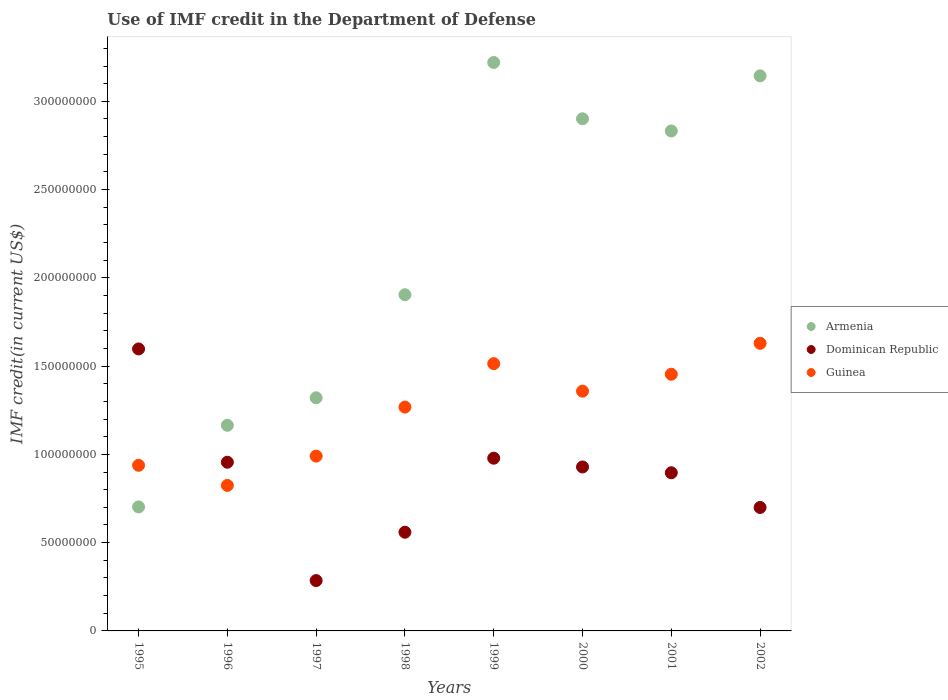How many different coloured dotlines are there?
Offer a very short reply. 3. Is the number of dotlines equal to the number of legend labels?
Ensure brevity in your answer.  Yes. What is the IMF credit in the Department of Defense in Armenia in 1995?
Ensure brevity in your answer.  7.02e+07. Across all years, what is the maximum IMF credit in the Department of Defense in Armenia?
Give a very brief answer. 3.22e+08. Across all years, what is the minimum IMF credit in the Department of Defense in Armenia?
Offer a terse response. 7.02e+07. What is the total IMF credit in the Department of Defense in Guinea in the graph?
Your answer should be very brief. 9.98e+08. What is the difference between the IMF credit in the Department of Defense in Guinea in 1995 and that in 1999?
Make the answer very short. -5.76e+07. What is the difference between the IMF credit in the Department of Defense in Guinea in 1998 and the IMF credit in the Department of Defense in Armenia in 2000?
Ensure brevity in your answer.  -1.63e+08. What is the average IMF credit in the Department of Defense in Armenia per year?
Offer a very short reply. 2.15e+08. In the year 2002, what is the difference between the IMF credit in the Department of Defense in Armenia and IMF credit in the Department of Defense in Dominican Republic?
Keep it short and to the point. 2.44e+08. What is the ratio of the IMF credit in the Department of Defense in Dominican Republic in 1996 to that in 1999?
Provide a short and direct response. 0.98. Is the IMF credit in the Department of Defense in Armenia in 1999 less than that in 2002?
Your response must be concise. No. What is the difference between the highest and the second highest IMF credit in the Department of Defense in Armenia?
Keep it short and to the point. 7.57e+06. What is the difference between the highest and the lowest IMF credit in the Department of Defense in Guinea?
Give a very brief answer. 8.05e+07. In how many years, is the IMF credit in the Department of Defense in Guinea greater than the average IMF credit in the Department of Defense in Guinea taken over all years?
Offer a very short reply. 5. Is the sum of the IMF credit in the Department of Defense in Dominican Republic in 1997 and 2002 greater than the maximum IMF credit in the Department of Defense in Guinea across all years?
Keep it short and to the point. No. Is it the case that in every year, the sum of the IMF credit in the Department of Defense in Dominican Republic and IMF credit in the Department of Defense in Guinea  is greater than the IMF credit in the Department of Defense in Armenia?
Provide a short and direct response. No. Does the IMF credit in the Department of Defense in Dominican Republic monotonically increase over the years?
Offer a terse response. No. Is the IMF credit in the Department of Defense in Armenia strictly greater than the IMF credit in the Department of Defense in Dominican Republic over the years?
Keep it short and to the point. No. How many dotlines are there?
Your answer should be very brief. 3. What is the difference between two consecutive major ticks on the Y-axis?
Your answer should be very brief. 5.00e+07. Are the values on the major ticks of Y-axis written in scientific E-notation?
Offer a terse response. No. Does the graph contain any zero values?
Provide a succinct answer. No. How many legend labels are there?
Ensure brevity in your answer.  3. How are the legend labels stacked?
Offer a very short reply. Vertical. What is the title of the graph?
Make the answer very short. Use of IMF credit in the Department of Defense. Does "Madagascar" appear as one of the legend labels in the graph?
Offer a very short reply. No. What is the label or title of the X-axis?
Offer a very short reply. Years. What is the label or title of the Y-axis?
Provide a short and direct response. IMF credit(in current US$). What is the IMF credit(in current US$) in Armenia in 1995?
Your answer should be compact. 7.02e+07. What is the IMF credit(in current US$) of Dominican Republic in 1995?
Your answer should be compact. 1.60e+08. What is the IMF credit(in current US$) of Guinea in 1995?
Give a very brief answer. 9.38e+07. What is the IMF credit(in current US$) of Armenia in 1996?
Your answer should be very brief. 1.16e+08. What is the IMF credit(in current US$) of Dominican Republic in 1996?
Keep it short and to the point. 9.56e+07. What is the IMF credit(in current US$) of Guinea in 1996?
Keep it short and to the point. 8.24e+07. What is the IMF credit(in current US$) of Armenia in 1997?
Keep it short and to the point. 1.32e+08. What is the IMF credit(in current US$) in Dominican Republic in 1997?
Your response must be concise. 2.85e+07. What is the IMF credit(in current US$) of Guinea in 1997?
Offer a terse response. 9.90e+07. What is the IMF credit(in current US$) of Armenia in 1998?
Make the answer very short. 1.90e+08. What is the IMF credit(in current US$) in Dominican Republic in 1998?
Offer a very short reply. 5.59e+07. What is the IMF credit(in current US$) in Guinea in 1998?
Ensure brevity in your answer.  1.27e+08. What is the IMF credit(in current US$) of Armenia in 1999?
Provide a succinct answer. 3.22e+08. What is the IMF credit(in current US$) of Dominican Republic in 1999?
Provide a short and direct response. 9.78e+07. What is the IMF credit(in current US$) of Guinea in 1999?
Offer a very short reply. 1.51e+08. What is the IMF credit(in current US$) in Armenia in 2000?
Give a very brief answer. 2.90e+08. What is the IMF credit(in current US$) in Dominican Republic in 2000?
Give a very brief answer. 9.29e+07. What is the IMF credit(in current US$) in Guinea in 2000?
Ensure brevity in your answer.  1.36e+08. What is the IMF credit(in current US$) in Armenia in 2001?
Keep it short and to the point. 2.83e+08. What is the IMF credit(in current US$) of Dominican Republic in 2001?
Offer a terse response. 8.96e+07. What is the IMF credit(in current US$) in Guinea in 2001?
Keep it short and to the point. 1.45e+08. What is the IMF credit(in current US$) in Armenia in 2002?
Your answer should be very brief. 3.14e+08. What is the IMF credit(in current US$) in Dominican Republic in 2002?
Offer a very short reply. 6.99e+07. What is the IMF credit(in current US$) of Guinea in 2002?
Provide a succinct answer. 1.63e+08. Across all years, what is the maximum IMF credit(in current US$) in Armenia?
Your answer should be very brief. 3.22e+08. Across all years, what is the maximum IMF credit(in current US$) of Dominican Republic?
Provide a succinct answer. 1.60e+08. Across all years, what is the maximum IMF credit(in current US$) of Guinea?
Your answer should be very brief. 1.63e+08. Across all years, what is the minimum IMF credit(in current US$) in Armenia?
Keep it short and to the point. 7.02e+07. Across all years, what is the minimum IMF credit(in current US$) in Dominican Republic?
Provide a succinct answer. 2.85e+07. Across all years, what is the minimum IMF credit(in current US$) in Guinea?
Offer a very short reply. 8.24e+07. What is the total IMF credit(in current US$) in Armenia in the graph?
Ensure brevity in your answer.  1.72e+09. What is the total IMF credit(in current US$) in Dominican Republic in the graph?
Make the answer very short. 6.90e+08. What is the total IMF credit(in current US$) in Guinea in the graph?
Make the answer very short. 9.98e+08. What is the difference between the IMF credit(in current US$) of Armenia in 1995 and that in 1996?
Ensure brevity in your answer.  -4.62e+07. What is the difference between the IMF credit(in current US$) of Dominican Republic in 1995 and that in 1996?
Make the answer very short. 6.42e+07. What is the difference between the IMF credit(in current US$) in Guinea in 1995 and that in 1996?
Your response must be concise. 1.14e+07. What is the difference between the IMF credit(in current US$) in Armenia in 1995 and that in 1997?
Offer a terse response. -6.18e+07. What is the difference between the IMF credit(in current US$) in Dominican Republic in 1995 and that in 1997?
Keep it short and to the point. 1.31e+08. What is the difference between the IMF credit(in current US$) in Guinea in 1995 and that in 1997?
Your answer should be compact. -5.21e+06. What is the difference between the IMF credit(in current US$) of Armenia in 1995 and that in 1998?
Your answer should be very brief. -1.20e+08. What is the difference between the IMF credit(in current US$) in Dominican Republic in 1995 and that in 1998?
Your response must be concise. 1.04e+08. What is the difference between the IMF credit(in current US$) in Guinea in 1995 and that in 1998?
Your answer should be compact. -3.30e+07. What is the difference between the IMF credit(in current US$) in Armenia in 1995 and that in 1999?
Provide a succinct answer. -2.52e+08. What is the difference between the IMF credit(in current US$) of Dominican Republic in 1995 and that in 1999?
Your response must be concise. 6.19e+07. What is the difference between the IMF credit(in current US$) of Guinea in 1995 and that in 1999?
Your answer should be very brief. -5.76e+07. What is the difference between the IMF credit(in current US$) of Armenia in 1995 and that in 2000?
Give a very brief answer. -2.20e+08. What is the difference between the IMF credit(in current US$) of Dominican Republic in 1995 and that in 2000?
Make the answer very short. 6.69e+07. What is the difference between the IMF credit(in current US$) in Guinea in 1995 and that in 2000?
Your answer should be very brief. -4.20e+07. What is the difference between the IMF credit(in current US$) of Armenia in 1995 and that in 2001?
Offer a very short reply. -2.13e+08. What is the difference between the IMF credit(in current US$) of Dominican Republic in 1995 and that in 2001?
Provide a succinct answer. 7.01e+07. What is the difference between the IMF credit(in current US$) of Guinea in 1995 and that in 2001?
Make the answer very short. -5.16e+07. What is the difference between the IMF credit(in current US$) in Armenia in 1995 and that in 2002?
Provide a succinct answer. -2.44e+08. What is the difference between the IMF credit(in current US$) of Dominican Republic in 1995 and that in 2002?
Your answer should be very brief. 8.98e+07. What is the difference between the IMF credit(in current US$) in Guinea in 1995 and that in 2002?
Keep it short and to the point. -6.91e+07. What is the difference between the IMF credit(in current US$) of Armenia in 1996 and that in 1997?
Offer a very short reply. -1.56e+07. What is the difference between the IMF credit(in current US$) in Dominican Republic in 1996 and that in 1997?
Make the answer very short. 6.70e+07. What is the difference between the IMF credit(in current US$) of Guinea in 1996 and that in 1997?
Your answer should be very brief. -1.66e+07. What is the difference between the IMF credit(in current US$) in Armenia in 1996 and that in 1998?
Give a very brief answer. -7.40e+07. What is the difference between the IMF credit(in current US$) in Dominican Republic in 1996 and that in 1998?
Provide a succinct answer. 3.97e+07. What is the difference between the IMF credit(in current US$) of Guinea in 1996 and that in 1998?
Your answer should be very brief. -4.44e+07. What is the difference between the IMF credit(in current US$) in Armenia in 1996 and that in 1999?
Ensure brevity in your answer.  -2.06e+08. What is the difference between the IMF credit(in current US$) in Dominican Republic in 1996 and that in 1999?
Your answer should be very brief. -2.28e+06. What is the difference between the IMF credit(in current US$) in Guinea in 1996 and that in 1999?
Keep it short and to the point. -6.90e+07. What is the difference between the IMF credit(in current US$) of Armenia in 1996 and that in 2000?
Ensure brevity in your answer.  -1.74e+08. What is the difference between the IMF credit(in current US$) of Dominican Republic in 1996 and that in 2000?
Provide a succinct answer. 2.68e+06. What is the difference between the IMF credit(in current US$) in Guinea in 1996 and that in 2000?
Your response must be concise. -5.34e+07. What is the difference between the IMF credit(in current US$) of Armenia in 1996 and that in 2001?
Keep it short and to the point. -1.67e+08. What is the difference between the IMF credit(in current US$) in Dominican Republic in 1996 and that in 2001?
Your answer should be compact. 5.97e+06. What is the difference between the IMF credit(in current US$) of Guinea in 1996 and that in 2001?
Give a very brief answer. -6.30e+07. What is the difference between the IMF credit(in current US$) of Armenia in 1996 and that in 2002?
Your answer should be very brief. -1.98e+08. What is the difference between the IMF credit(in current US$) in Dominican Republic in 1996 and that in 2002?
Your answer should be very brief. 2.56e+07. What is the difference between the IMF credit(in current US$) in Guinea in 1996 and that in 2002?
Make the answer very short. -8.05e+07. What is the difference between the IMF credit(in current US$) in Armenia in 1997 and that in 1998?
Provide a short and direct response. -5.84e+07. What is the difference between the IMF credit(in current US$) of Dominican Republic in 1997 and that in 1998?
Keep it short and to the point. -2.74e+07. What is the difference between the IMF credit(in current US$) in Guinea in 1997 and that in 1998?
Your response must be concise. -2.78e+07. What is the difference between the IMF credit(in current US$) of Armenia in 1997 and that in 1999?
Provide a succinct answer. -1.90e+08. What is the difference between the IMF credit(in current US$) of Dominican Republic in 1997 and that in 1999?
Your answer should be compact. -6.93e+07. What is the difference between the IMF credit(in current US$) of Guinea in 1997 and that in 1999?
Offer a terse response. -5.24e+07. What is the difference between the IMF credit(in current US$) of Armenia in 1997 and that in 2000?
Your response must be concise. -1.58e+08. What is the difference between the IMF credit(in current US$) in Dominican Republic in 1997 and that in 2000?
Offer a terse response. -6.44e+07. What is the difference between the IMF credit(in current US$) in Guinea in 1997 and that in 2000?
Provide a short and direct response. -3.68e+07. What is the difference between the IMF credit(in current US$) of Armenia in 1997 and that in 2001?
Your answer should be very brief. -1.51e+08. What is the difference between the IMF credit(in current US$) of Dominican Republic in 1997 and that in 2001?
Offer a terse response. -6.11e+07. What is the difference between the IMF credit(in current US$) of Guinea in 1997 and that in 2001?
Give a very brief answer. -4.64e+07. What is the difference between the IMF credit(in current US$) in Armenia in 1997 and that in 2002?
Provide a succinct answer. -1.82e+08. What is the difference between the IMF credit(in current US$) of Dominican Republic in 1997 and that in 2002?
Provide a succinct answer. -4.14e+07. What is the difference between the IMF credit(in current US$) of Guinea in 1997 and that in 2002?
Provide a succinct answer. -6.39e+07. What is the difference between the IMF credit(in current US$) in Armenia in 1998 and that in 1999?
Your answer should be very brief. -1.32e+08. What is the difference between the IMF credit(in current US$) of Dominican Republic in 1998 and that in 1999?
Keep it short and to the point. -4.19e+07. What is the difference between the IMF credit(in current US$) of Guinea in 1998 and that in 1999?
Give a very brief answer. -2.46e+07. What is the difference between the IMF credit(in current US$) of Armenia in 1998 and that in 2000?
Ensure brevity in your answer.  -9.97e+07. What is the difference between the IMF credit(in current US$) of Dominican Republic in 1998 and that in 2000?
Make the answer very short. -3.70e+07. What is the difference between the IMF credit(in current US$) in Guinea in 1998 and that in 2000?
Provide a succinct answer. -9.02e+06. What is the difference between the IMF credit(in current US$) of Armenia in 1998 and that in 2001?
Offer a terse response. -9.28e+07. What is the difference between the IMF credit(in current US$) of Dominican Republic in 1998 and that in 2001?
Provide a succinct answer. -3.37e+07. What is the difference between the IMF credit(in current US$) of Guinea in 1998 and that in 2001?
Offer a terse response. -1.86e+07. What is the difference between the IMF credit(in current US$) of Armenia in 1998 and that in 2002?
Keep it short and to the point. -1.24e+08. What is the difference between the IMF credit(in current US$) of Dominican Republic in 1998 and that in 2002?
Make the answer very short. -1.40e+07. What is the difference between the IMF credit(in current US$) in Guinea in 1998 and that in 2002?
Offer a terse response. -3.61e+07. What is the difference between the IMF credit(in current US$) in Armenia in 1999 and that in 2000?
Ensure brevity in your answer.  3.19e+07. What is the difference between the IMF credit(in current US$) in Dominican Republic in 1999 and that in 2000?
Make the answer very short. 4.96e+06. What is the difference between the IMF credit(in current US$) in Guinea in 1999 and that in 2000?
Provide a short and direct response. 1.56e+07. What is the difference between the IMF credit(in current US$) in Armenia in 1999 and that in 2001?
Make the answer very short. 3.88e+07. What is the difference between the IMF credit(in current US$) of Dominican Republic in 1999 and that in 2001?
Provide a short and direct response. 8.25e+06. What is the difference between the IMF credit(in current US$) in Guinea in 1999 and that in 2001?
Your answer should be compact. 6.01e+06. What is the difference between the IMF credit(in current US$) in Armenia in 1999 and that in 2002?
Make the answer very short. 7.57e+06. What is the difference between the IMF credit(in current US$) of Dominican Republic in 1999 and that in 2002?
Offer a very short reply. 2.79e+07. What is the difference between the IMF credit(in current US$) in Guinea in 1999 and that in 2002?
Offer a terse response. -1.15e+07. What is the difference between the IMF credit(in current US$) of Armenia in 2000 and that in 2001?
Your response must be concise. 6.90e+06. What is the difference between the IMF credit(in current US$) of Dominican Republic in 2000 and that in 2001?
Provide a succinct answer. 3.29e+06. What is the difference between the IMF credit(in current US$) in Guinea in 2000 and that in 2001?
Keep it short and to the point. -9.59e+06. What is the difference between the IMF credit(in current US$) of Armenia in 2000 and that in 2002?
Offer a terse response. -2.43e+07. What is the difference between the IMF credit(in current US$) of Dominican Republic in 2000 and that in 2002?
Offer a very short reply. 2.30e+07. What is the difference between the IMF credit(in current US$) of Guinea in 2000 and that in 2002?
Provide a succinct answer. -2.71e+07. What is the difference between the IMF credit(in current US$) of Armenia in 2001 and that in 2002?
Keep it short and to the point. -3.12e+07. What is the difference between the IMF credit(in current US$) of Dominican Republic in 2001 and that in 2002?
Offer a terse response. 1.97e+07. What is the difference between the IMF credit(in current US$) in Guinea in 2001 and that in 2002?
Keep it short and to the point. -1.75e+07. What is the difference between the IMF credit(in current US$) of Armenia in 1995 and the IMF credit(in current US$) of Dominican Republic in 1996?
Ensure brevity in your answer.  -2.53e+07. What is the difference between the IMF credit(in current US$) in Armenia in 1995 and the IMF credit(in current US$) in Guinea in 1996?
Offer a very short reply. -1.22e+07. What is the difference between the IMF credit(in current US$) of Dominican Republic in 1995 and the IMF credit(in current US$) of Guinea in 1996?
Provide a succinct answer. 7.73e+07. What is the difference between the IMF credit(in current US$) in Armenia in 1995 and the IMF credit(in current US$) in Dominican Republic in 1997?
Provide a short and direct response. 4.17e+07. What is the difference between the IMF credit(in current US$) of Armenia in 1995 and the IMF credit(in current US$) of Guinea in 1997?
Offer a terse response. -2.88e+07. What is the difference between the IMF credit(in current US$) of Dominican Republic in 1995 and the IMF credit(in current US$) of Guinea in 1997?
Ensure brevity in your answer.  6.07e+07. What is the difference between the IMF credit(in current US$) in Armenia in 1995 and the IMF credit(in current US$) in Dominican Republic in 1998?
Keep it short and to the point. 1.43e+07. What is the difference between the IMF credit(in current US$) in Armenia in 1995 and the IMF credit(in current US$) in Guinea in 1998?
Provide a short and direct response. -5.66e+07. What is the difference between the IMF credit(in current US$) in Dominican Republic in 1995 and the IMF credit(in current US$) in Guinea in 1998?
Ensure brevity in your answer.  3.29e+07. What is the difference between the IMF credit(in current US$) of Armenia in 1995 and the IMF credit(in current US$) of Dominican Republic in 1999?
Offer a terse response. -2.76e+07. What is the difference between the IMF credit(in current US$) in Armenia in 1995 and the IMF credit(in current US$) in Guinea in 1999?
Your response must be concise. -8.12e+07. What is the difference between the IMF credit(in current US$) in Dominican Republic in 1995 and the IMF credit(in current US$) in Guinea in 1999?
Keep it short and to the point. 8.33e+06. What is the difference between the IMF credit(in current US$) of Armenia in 1995 and the IMF credit(in current US$) of Dominican Republic in 2000?
Give a very brief answer. -2.26e+07. What is the difference between the IMF credit(in current US$) in Armenia in 1995 and the IMF credit(in current US$) in Guinea in 2000?
Provide a succinct answer. -6.56e+07. What is the difference between the IMF credit(in current US$) of Dominican Republic in 1995 and the IMF credit(in current US$) of Guinea in 2000?
Offer a terse response. 2.39e+07. What is the difference between the IMF credit(in current US$) in Armenia in 1995 and the IMF credit(in current US$) in Dominican Republic in 2001?
Provide a short and direct response. -1.93e+07. What is the difference between the IMF credit(in current US$) of Armenia in 1995 and the IMF credit(in current US$) of Guinea in 2001?
Your answer should be compact. -7.52e+07. What is the difference between the IMF credit(in current US$) of Dominican Republic in 1995 and the IMF credit(in current US$) of Guinea in 2001?
Your answer should be very brief. 1.43e+07. What is the difference between the IMF credit(in current US$) of Armenia in 1995 and the IMF credit(in current US$) of Dominican Republic in 2002?
Keep it short and to the point. 3.11e+05. What is the difference between the IMF credit(in current US$) in Armenia in 1995 and the IMF credit(in current US$) in Guinea in 2002?
Your response must be concise. -9.27e+07. What is the difference between the IMF credit(in current US$) in Dominican Republic in 1995 and the IMF credit(in current US$) in Guinea in 2002?
Make the answer very short. -3.18e+06. What is the difference between the IMF credit(in current US$) in Armenia in 1996 and the IMF credit(in current US$) in Dominican Republic in 1997?
Make the answer very short. 8.80e+07. What is the difference between the IMF credit(in current US$) in Armenia in 1996 and the IMF credit(in current US$) in Guinea in 1997?
Provide a short and direct response. 1.74e+07. What is the difference between the IMF credit(in current US$) of Dominican Republic in 1996 and the IMF credit(in current US$) of Guinea in 1997?
Offer a terse response. -3.47e+06. What is the difference between the IMF credit(in current US$) in Armenia in 1996 and the IMF credit(in current US$) in Dominican Republic in 1998?
Offer a terse response. 6.06e+07. What is the difference between the IMF credit(in current US$) in Armenia in 1996 and the IMF credit(in current US$) in Guinea in 1998?
Provide a short and direct response. -1.03e+07. What is the difference between the IMF credit(in current US$) of Dominican Republic in 1996 and the IMF credit(in current US$) of Guinea in 1998?
Your answer should be very brief. -3.12e+07. What is the difference between the IMF credit(in current US$) of Armenia in 1996 and the IMF credit(in current US$) of Dominican Republic in 1999?
Provide a succinct answer. 1.86e+07. What is the difference between the IMF credit(in current US$) of Armenia in 1996 and the IMF credit(in current US$) of Guinea in 1999?
Keep it short and to the point. -3.49e+07. What is the difference between the IMF credit(in current US$) in Dominican Republic in 1996 and the IMF credit(in current US$) in Guinea in 1999?
Keep it short and to the point. -5.58e+07. What is the difference between the IMF credit(in current US$) in Armenia in 1996 and the IMF credit(in current US$) in Dominican Republic in 2000?
Provide a short and direct response. 2.36e+07. What is the difference between the IMF credit(in current US$) of Armenia in 1996 and the IMF credit(in current US$) of Guinea in 2000?
Your answer should be compact. -1.93e+07. What is the difference between the IMF credit(in current US$) in Dominican Republic in 1996 and the IMF credit(in current US$) in Guinea in 2000?
Your response must be concise. -4.02e+07. What is the difference between the IMF credit(in current US$) of Armenia in 1996 and the IMF credit(in current US$) of Dominican Republic in 2001?
Provide a short and direct response. 2.69e+07. What is the difference between the IMF credit(in current US$) of Armenia in 1996 and the IMF credit(in current US$) of Guinea in 2001?
Give a very brief answer. -2.89e+07. What is the difference between the IMF credit(in current US$) in Dominican Republic in 1996 and the IMF credit(in current US$) in Guinea in 2001?
Offer a very short reply. -4.98e+07. What is the difference between the IMF credit(in current US$) in Armenia in 1996 and the IMF credit(in current US$) in Dominican Republic in 2002?
Give a very brief answer. 4.65e+07. What is the difference between the IMF credit(in current US$) of Armenia in 1996 and the IMF credit(in current US$) of Guinea in 2002?
Your response must be concise. -4.64e+07. What is the difference between the IMF credit(in current US$) of Dominican Republic in 1996 and the IMF credit(in current US$) of Guinea in 2002?
Offer a very short reply. -6.74e+07. What is the difference between the IMF credit(in current US$) of Armenia in 1997 and the IMF credit(in current US$) of Dominican Republic in 1998?
Offer a terse response. 7.62e+07. What is the difference between the IMF credit(in current US$) in Armenia in 1997 and the IMF credit(in current US$) in Guinea in 1998?
Your response must be concise. 5.27e+06. What is the difference between the IMF credit(in current US$) of Dominican Republic in 1997 and the IMF credit(in current US$) of Guinea in 1998?
Offer a very short reply. -9.83e+07. What is the difference between the IMF credit(in current US$) of Armenia in 1997 and the IMF credit(in current US$) of Dominican Republic in 1999?
Offer a terse response. 3.42e+07. What is the difference between the IMF credit(in current US$) of Armenia in 1997 and the IMF credit(in current US$) of Guinea in 1999?
Give a very brief answer. -1.93e+07. What is the difference between the IMF credit(in current US$) of Dominican Republic in 1997 and the IMF credit(in current US$) of Guinea in 1999?
Your answer should be very brief. -1.23e+08. What is the difference between the IMF credit(in current US$) of Armenia in 1997 and the IMF credit(in current US$) of Dominican Republic in 2000?
Your response must be concise. 3.92e+07. What is the difference between the IMF credit(in current US$) in Armenia in 1997 and the IMF credit(in current US$) in Guinea in 2000?
Ensure brevity in your answer.  -3.74e+06. What is the difference between the IMF credit(in current US$) of Dominican Republic in 1997 and the IMF credit(in current US$) of Guinea in 2000?
Your answer should be compact. -1.07e+08. What is the difference between the IMF credit(in current US$) in Armenia in 1997 and the IMF credit(in current US$) in Dominican Republic in 2001?
Make the answer very short. 4.25e+07. What is the difference between the IMF credit(in current US$) in Armenia in 1997 and the IMF credit(in current US$) in Guinea in 2001?
Your answer should be very brief. -1.33e+07. What is the difference between the IMF credit(in current US$) of Dominican Republic in 1997 and the IMF credit(in current US$) of Guinea in 2001?
Your answer should be very brief. -1.17e+08. What is the difference between the IMF credit(in current US$) of Armenia in 1997 and the IMF credit(in current US$) of Dominican Republic in 2002?
Keep it short and to the point. 6.21e+07. What is the difference between the IMF credit(in current US$) of Armenia in 1997 and the IMF credit(in current US$) of Guinea in 2002?
Provide a short and direct response. -3.09e+07. What is the difference between the IMF credit(in current US$) of Dominican Republic in 1997 and the IMF credit(in current US$) of Guinea in 2002?
Your answer should be very brief. -1.34e+08. What is the difference between the IMF credit(in current US$) of Armenia in 1998 and the IMF credit(in current US$) of Dominican Republic in 1999?
Your answer should be very brief. 9.26e+07. What is the difference between the IMF credit(in current US$) in Armenia in 1998 and the IMF credit(in current US$) in Guinea in 1999?
Your answer should be very brief. 3.90e+07. What is the difference between the IMF credit(in current US$) in Dominican Republic in 1998 and the IMF credit(in current US$) in Guinea in 1999?
Ensure brevity in your answer.  -9.55e+07. What is the difference between the IMF credit(in current US$) in Armenia in 1998 and the IMF credit(in current US$) in Dominican Republic in 2000?
Offer a very short reply. 9.76e+07. What is the difference between the IMF credit(in current US$) of Armenia in 1998 and the IMF credit(in current US$) of Guinea in 2000?
Give a very brief answer. 5.46e+07. What is the difference between the IMF credit(in current US$) in Dominican Republic in 1998 and the IMF credit(in current US$) in Guinea in 2000?
Your answer should be very brief. -7.99e+07. What is the difference between the IMF credit(in current US$) of Armenia in 1998 and the IMF credit(in current US$) of Dominican Republic in 2001?
Provide a short and direct response. 1.01e+08. What is the difference between the IMF credit(in current US$) of Armenia in 1998 and the IMF credit(in current US$) of Guinea in 2001?
Give a very brief answer. 4.51e+07. What is the difference between the IMF credit(in current US$) in Dominican Republic in 1998 and the IMF credit(in current US$) in Guinea in 2001?
Offer a very short reply. -8.95e+07. What is the difference between the IMF credit(in current US$) in Armenia in 1998 and the IMF credit(in current US$) in Dominican Republic in 2002?
Make the answer very short. 1.21e+08. What is the difference between the IMF credit(in current US$) in Armenia in 1998 and the IMF credit(in current US$) in Guinea in 2002?
Provide a short and direct response. 2.75e+07. What is the difference between the IMF credit(in current US$) of Dominican Republic in 1998 and the IMF credit(in current US$) of Guinea in 2002?
Give a very brief answer. -1.07e+08. What is the difference between the IMF credit(in current US$) in Armenia in 1999 and the IMF credit(in current US$) in Dominican Republic in 2000?
Keep it short and to the point. 2.29e+08. What is the difference between the IMF credit(in current US$) in Armenia in 1999 and the IMF credit(in current US$) in Guinea in 2000?
Your response must be concise. 1.86e+08. What is the difference between the IMF credit(in current US$) of Dominican Republic in 1999 and the IMF credit(in current US$) of Guinea in 2000?
Provide a short and direct response. -3.80e+07. What is the difference between the IMF credit(in current US$) of Armenia in 1999 and the IMF credit(in current US$) of Dominican Republic in 2001?
Your answer should be very brief. 2.32e+08. What is the difference between the IMF credit(in current US$) of Armenia in 1999 and the IMF credit(in current US$) of Guinea in 2001?
Provide a short and direct response. 1.77e+08. What is the difference between the IMF credit(in current US$) of Dominican Republic in 1999 and the IMF credit(in current US$) of Guinea in 2001?
Offer a very short reply. -4.75e+07. What is the difference between the IMF credit(in current US$) of Armenia in 1999 and the IMF credit(in current US$) of Dominican Republic in 2002?
Make the answer very short. 2.52e+08. What is the difference between the IMF credit(in current US$) in Armenia in 1999 and the IMF credit(in current US$) in Guinea in 2002?
Give a very brief answer. 1.59e+08. What is the difference between the IMF credit(in current US$) of Dominican Republic in 1999 and the IMF credit(in current US$) of Guinea in 2002?
Provide a succinct answer. -6.51e+07. What is the difference between the IMF credit(in current US$) of Armenia in 2000 and the IMF credit(in current US$) of Dominican Republic in 2001?
Ensure brevity in your answer.  2.01e+08. What is the difference between the IMF credit(in current US$) in Armenia in 2000 and the IMF credit(in current US$) in Guinea in 2001?
Your answer should be very brief. 1.45e+08. What is the difference between the IMF credit(in current US$) of Dominican Republic in 2000 and the IMF credit(in current US$) of Guinea in 2001?
Your answer should be very brief. -5.25e+07. What is the difference between the IMF credit(in current US$) in Armenia in 2000 and the IMF credit(in current US$) in Dominican Republic in 2002?
Offer a very short reply. 2.20e+08. What is the difference between the IMF credit(in current US$) in Armenia in 2000 and the IMF credit(in current US$) in Guinea in 2002?
Your answer should be very brief. 1.27e+08. What is the difference between the IMF credit(in current US$) of Dominican Republic in 2000 and the IMF credit(in current US$) of Guinea in 2002?
Offer a terse response. -7.00e+07. What is the difference between the IMF credit(in current US$) of Armenia in 2001 and the IMF credit(in current US$) of Dominican Republic in 2002?
Your answer should be compact. 2.13e+08. What is the difference between the IMF credit(in current US$) of Armenia in 2001 and the IMF credit(in current US$) of Guinea in 2002?
Provide a short and direct response. 1.20e+08. What is the difference between the IMF credit(in current US$) in Dominican Republic in 2001 and the IMF credit(in current US$) in Guinea in 2002?
Provide a succinct answer. -7.33e+07. What is the average IMF credit(in current US$) in Armenia per year?
Your answer should be very brief. 2.15e+08. What is the average IMF credit(in current US$) in Dominican Republic per year?
Your answer should be very brief. 8.62e+07. What is the average IMF credit(in current US$) of Guinea per year?
Offer a very short reply. 1.25e+08. In the year 1995, what is the difference between the IMF credit(in current US$) in Armenia and IMF credit(in current US$) in Dominican Republic?
Your answer should be very brief. -8.95e+07. In the year 1995, what is the difference between the IMF credit(in current US$) of Armenia and IMF credit(in current US$) of Guinea?
Your answer should be compact. -2.36e+07. In the year 1995, what is the difference between the IMF credit(in current US$) of Dominican Republic and IMF credit(in current US$) of Guinea?
Ensure brevity in your answer.  6.59e+07. In the year 1996, what is the difference between the IMF credit(in current US$) in Armenia and IMF credit(in current US$) in Dominican Republic?
Ensure brevity in your answer.  2.09e+07. In the year 1996, what is the difference between the IMF credit(in current US$) of Armenia and IMF credit(in current US$) of Guinea?
Make the answer very short. 3.40e+07. In the year 1996, what is the difference between the IMF credit(in current US$) in Dominican Republic and IMF credit(in current US$) in Guinea?
Provide a short and direct response. 1.31e+07. In the year 1997, what is the difference between the IMF credit(in current US$) of Armenia and IMF credit(in current US$) of Dominican Republic?
Offer a very short reply. 1.04e+08. In the year 1997, what is the difference between the IMF credit(in current US$) in Armenia and IMF credit(in current US$) in Guinea?
Offer a very short reply. 3.30e+07. In the year 1997, what is the difference between the IMF credit(in current US$) of Dominican Republic and IMF credit(in current US$) of Guinea?
Your answer should be very brief. -7.05e+07. In the year 1998, what is the difference between the IMF credit(in current US$) in Armenia and IMF credit(in current US$) in Dominican Republic?
Your answer should be compact. 1.35e+08. In the year 1998, what is the difference between the IMF credit(in current US$) of Armenia and IMF credit(in current US$) of Guinea?
Ensure brevity in your answer.  6.37e+07. In the year 1998, what is the difference between the IMF credit(in current US$) of Dominican Republic and IMF credit(in current US$) of Guinea?
Offer a terse response. -7.09e+07. In the year 1999, what is the difference between the IMF credit(in current US$) in Armenia and IMF credit(in current US$) in Dominican Republic?
Provide a succinct answer. 2.24e+08. In the year 1999, what is the difference between the IMF credit(in current US$) of Armenia and IMF credit(in current US$) of Guinea?
Your answer should be compact. 1.71e+08. In the year 1999, what is the difference between the IMF credit(in current US$) in Dominican Republic and IMF credit(in current US$) in Guinea?
Your answer should be compact. -5.36e+07. In the year 2000, what is the difference between the IMF credit(in current US$) in Armenia and IMF credit(in current US$) in Dominican Republic?
Provide a short and direct response. 1.97e+08. In the year 2000, what is the difference between the IMF credit(in current US$) of Armenia and IMF credit(in current US$) of Guinea?
Your answer should be very brief. 1.54e+08. In the year 2000, what is the difference between the IMF credit(in current US$) of Dominican Republic and IMF credit(in current US$) of Guinea?
Provide a succinct answer. -4.29e+07. In the year 2001, what is the difference between the IMF credit(in current US$) in Armenia and IMF credit(in current US$) in Dominican Republic?
Give a very brief answer. 1.94e+08. In the year 2001, what is the difference between the IMF credit(in current US$) of Armenia and IMF credit(in current US$) of Guinea?
Keep it short and to the point. 1.38e+08. In the year 2001, what is the difference between the IMF credit(in current US$) in Dominican Republic and IMF credit(in current US$) in Guinea?
Offer a very short reply. -5.58e+07. In the year 2002, what is the difference between the IMF credit(in current US$) in Armenia and IMF credit(in current US$) in Dominican Republic?
Your answer should be very brief. 2.44e+08. In the year 2002, what is the difference between the IMF credit(in current US$) of Armenia and IMF credit(in current US$) of Guinea?
Keep it short and to the point. 1.52e+08. In the year 2002, what is the difference between the IMF credit(in current US$) in Dominican Republic and IMF credit(in current US$) in Guinea?
Make the answer very short. -9.30e+07. What is the ratio of the IMF credit(in current US$) of Armenia in 1995 to that in 1996?
Your response must be concise. 0.6. What is the ratio of the IMF credit(in current US$) of Dominican Republic in 1995 to that in 1996?
Make the answer very short. 1.67. What is the ratio of the IMF credit(in current US$) of Guinea in 1995 to that in 1996?
Offer a very short reply. 1.14. What is the ratio of the IMF credit(in current US$) of Armenia in 1995 to that in 1997?
Make the answer very short. 0.53. What is the ratio of the IMF credit(in current US$) in Dominican Republic in 1995 to that in 1997?
Give a very brief answer. 5.6. What is the ratio of the IMF credit(in current US$) of Armenia in 1995 to that in 1998?
Provide a short and direct response. 0.37. What is the ratio of the IMF credit(in current US$) in Dominican Republic in 1995 to that in 1998?
Offer a very short reply. 2.86. What is the ratio of the IMF credit(in current US$) of Guinea in 1995 to that in 1998?
Give a very brief answer. 0.74. What is the ratio of the IMF credit(in current US$) of Armenia in 1995 to that in 1999?
Provide a succinct answer. 0.22. What is the ratio of the IMF credit(in current US$) in Dominican Republic in 1995 to that in 1999?
Provide a succinct answer. 1.63. What is the ratio of the IMF credit(in current US$) of Guinea in 1995 to that in 1999?
Provide a succinct answer. 0.62. What is the ratio of the IMF credit(in current US$) in Armenia in 1995 to that in 2000?
Provide a succinct answer. 0.24. What is the ratio of the IMF credit(in current US$) of Dominican Republic in 1995 to that in 2000?
Offer a terse response. 1.72. What is the ratio of the IMF credit(in current US$) of Guinea in 1995 to that in 2000?
Your answer should be compact. 0.69. What is the ratio of the IMF credit(in current US$) in Armenia in 1995 to that in 2001?
Your response must be concise. 0.25. What is the ratio of the IMF credit(in current US$) of Dominican Republic in 1995 to that in 2001?
Make the answer very short. 1.78. What is the ratio of the IMF credit(in current US$) in Guinea in 1995 to that in 2001?
Make the answer very short. 0.65. What is the ratio of the IMF credit(in current US$) in Armenia in 1995 to that in 2002?
Your answer should be very brief. 0.22. What is the ratio of the IMF credit(in current US$) in Dominican Republic in 1995 to that in 2002?
Your answer should be compact. 2.28. What is the ratio of the IMF credit(in current US$) in Guinea in 1995 to that in 2002?
Ensure brevity in your answer.  0.58. What is the ratio of the IMF credit(in current US$) of Armenia in 1996 to that in 1997?
Your answer should be very brief. 0.88. What is the ratio of the IMF credit(in current US$) in Dominican Republic in 1996 to that in 1997?
Give a very brief answer. 3.35. What is the ratio of the IMF credit(in current US$) in Guinea in 1996 to that in 1997?
Offer a terse response. 0.83. What is the ratio of the IMF credit(in current US$) in Armenia in 1996 to that in 1998?
Make the answer very short. 0.61. What is the ratio of the IMF credit(in current US$) in Dominican Republic in 1996 to that in 1998?
Your answer should be very brief. 1.71. What is the ratio of the IMF credit(in current US$) of Guinea in 1996 to that in 1998?
Provide a succinct answer. 0.65. What is the ratio of the IMF credit(in current US$) in Armenia in 1996 to that in 1999?
Offer a very short reply. 0.36. What is the ratio of the IMF credit(in current US$) of Dominican Republic in 1996 to that in 1999?
Your response must be concise. 0.98. What is the ratio of the IMF credit(in current US$) in Guinea in 1996 to that in 1999?
Offer a very short reply. 0.54. What is the ratio of the IMF credit(in current US$) of Armenia in 1996 to that in 2000?
Give a very brief answer. 0.4. What is the ratio of the IMF credit(in current US$) of Dominican Republic in 1996 to that in 2000?
Keep it short and to the point. 1.03. What is the ratio of the IMF credit(in current US$) of Guinea in 1996 to that in 2000?
Offer a terse response. 0.61. What is the ratio of the IMF credit(in current US$) of Armenia in 1996 to that in 2001?
Give a very brief answer. 0.41. What is the ratio of the IMF credit(in current US$) in Dominican Republic in 1996 to that in 2001?
Offer a terse response. 1.07. What is the ratio of the IMF credit(in current US$) in Guinea in 1996 to that in 2001?
Provide a succinct answer. 0.57. What is the ratio of the IMF credit(in current US$) in Armenia in 1996 to that in 2002?
Provide a succinct answer. 0.37. What is the ratio of the IMF credit(in current US$) in Dominican Republic in 1996 to that in 2002?
Offer a terse response. 1.37. What is the ratio of the IMF credit(in current US$) in Guinea in 1996 to that in 2002?
Keep it short and to the point. 0.51. What is the ratio of the IMF credit(in current US$) of Armenia in 1997 to that in 1998?
Your response must be concise. 0.69. What is the ratio of the IMF credit(in current US$) of Dominican Republic in 1997 to that in 1998?
Keep it short and to the point. 0.51. What is the ratio of the IMF credit(in current US$) in Guinea in 1997 to that in 1998?
Provide a short and direct response. 0.78. What is the ratio of the IMF credit(in current US$) in Armenia in 1997 to that in 1999?
Provide a short and direct response. 0.41. What is the ratio of the IMF credit(in current US$) in Dominican Republic in 1997 to that in 1999?
Offer a terse response. 0.29. What is the ratio of the IMF credit(in current US$) of Guinea in 1997 to that in 1999?
Provide a short and direct response. 0.65. What is the ratio of the IMF credit(in current US$) of Armenia in 1997 to that in 2000?
Make the answer very short. 0.46. What is the ratio of the IMF credit(in current US$) in Dominican Republic in 1997 to that in 2000?
Your answer should be very brief. 0.31. What is the ratio of the IMF credit(in current US$) in Guinea in 1997 to that in 2000?
Provide a succinct answer. 0.73. What is the ratio of the IMF credit(in current US$) of Armenia in 1997 to that in 2001?
Your answer should be very brief. 0.47. What is the ratio of the IMF credit(in current US$) of Dominican Republic in 1997 to that in 2001?
Offer a terse response. 0.32. What is the ratio of the IMF credit(in current US$) in Guinea in 1997 to that in 2001?
Your response must be concise. 0.68. What is the ratio of the IMF credit(in current US$) of Armenia in 1997 to that in 2002?
Offer a very short reply. 0.42. What is the ratio of the IMF credit(in current US$) of Dominican Republic in 1997 to that in 2002?
Ensure brevity in your answer.  0.41. What is the ratio of the IMF credit(in current US$) in Guinea in 1997 to that in 2002?
Your answer should be very brief. 0.61. What is the ratio of the IMF credit(in current US$) of Armenia in 1998 to that in 1999?
Your answer should be compact. 0.59. What is the ratio of the IMF credit(in current US$) of Dominican Republic in 1998 to that in 1999?
Provide a short and direct response. 0.57. What is the ratio of the IMF credit(in current US$) in Guinea in 1998 to that in 1999?
Keep it short and to the point. 0.84. What is the ratio of the IMF credit(in current US$) in Armenia in 1998 to that in 2000?
Offer a very short reply. 0.66. What is the ratio of the IMF credit(in current US$) in Dominican Republic in 1998 to that in 2000?
Your answer should be very brief. 0.6. What is the ratio of the IMF credit(in current US$) of Guinea in 1998 to that in 2000?
Your answer should be compact. 0.93. What is the ratio of the IMF credit(in current US$) of Armenia in 1998 to that in 2001?
Your answer should be compact. 0.67. What is the ratio of the IMF credit(in current US$) of Dominican Republic in 1998 to that in 2001?
Keep it short and to the point. 0.62. What is the ratio of the IMF credit(in current US$) of Guinea in 1998 to that in 2001?
Give a very brief answer. 0.87. What is the ratio of the IMF credit(in current US$) of Armenia in 1998 to that in 2002?
Provide a short and direct response. 0.61. What is the ratio of the IMF credit(in current US$) in Dominican Republic in 1998 to that in 2002?
Give a very brief answer. 0.8. What is the ratio of the IMF credit(in current US$) of Guinea in 1998 to that in 2002?
Your response must be concise. 0.78. What is the ratio of the IMF credit(in current US$) of Armenia in 1999 to that in 2000?
Your answer should be compact. 1.11. What is the ratio of the IMF credit(in current US$) of Dominican Republic in 1999 to that in 2000?
Provide a succinct answer. 1.05. What is the ratio of the IMF credit(in current US$) in Guinea in 1999 to that in 2000?
Give a very brief answer. 1.11. What is the ratio of the IMF credit(in current US$) in Armenia in 1999 to that in 2001?
Provide a short and direct response. 1.14. What is the ratio of the IMF credit(in current US$) in Dominican Republic in 1999 to that in 2001?
Your answer should be compact. 1.09. What is the ratio of the IMF credit(in current US$) of Guinea in 1999 to that in 2001?
Provide a succinct answer. 1.04. What is the ratio of the IMF credit(in current US$) in Armenia in 1999 to that in 2002?
Make the answer very short. 1.02. What is the ratio of the IMF credit(in current US$) of Dominican Republic in 1999 to that in 2002?
Provide a short and direct response. 1.4. What is the ratio of the IMF credit(in current US$) in Guinea in 1999 to that in 2002?
Offer a terse response. 0.93. What is the ratio of the IMF credit(in current US$) in Armenia in 2000 to that in 2001?
Provide a short and direct response. 1.02. What is the ratio of the IMF credit(in current US$) of Dominican Republic in 2000 to that in 2001?
Offer a terse response. 1.04. What is the ratio of the IMF credit(in current US$) of Guinea in 2000 to that in 2001?
Make the answer very short. 0.93. What is the ratio of the IMF credit(in current US$) in Armenia in 2000 to that in 2002?
Give a very brief answer. 0.92. What is the ratio of the IMF credit(in current US$) of Dominican Republic in 2000 to that in 2002?
Offer a very short reply. 1.33. What is the ratio of the IMF credit(in current US$) in Guinea in 2000 to that in 2002?
Provide a succinct answer. 0.83. What is the ratio of the IMF credit(in current US$) of Armenia in 2001 to that in 2002?
Give a very brief answer. 0.9. What is the ratio of the IMF credit(in current US$) of Dominican Republic in 2001 to that in 2002?
Ensure brevity in your answer.  1.28. What is the ratio of the IMF credit(in current US$) in Guinea in 2001 to that in 2002?
Ensure brevity in your answer.  0.89. What is the difference between the highest and the second highest IMF credit(in current US$) of Armenia?
Give a very brief answer. 7.57e+06. What is the difference between the highest and the second highest IMF credit(in current US$) in Dominican Republic?
Give a very brief answer. 6.19e+07. What is the difference between the highest and the second highest IMF credit(in current US$) of Guinea?
Give a very brief answer. 1.15e+07. What is the difference between the highest and the lowest IMF credit(in current US$) in Armenia?
Provide a short and direct response. 2.52e+08. What is the difference between the highest and the lowest IMF credit(in current US$) in Dominican Republic?
Offer a terse response. 1.31e+08. What is the difference between the highest and the lowest IMF credit(in current US$) of Guinea?
Your answer should be very brief. 8.05e+07. 